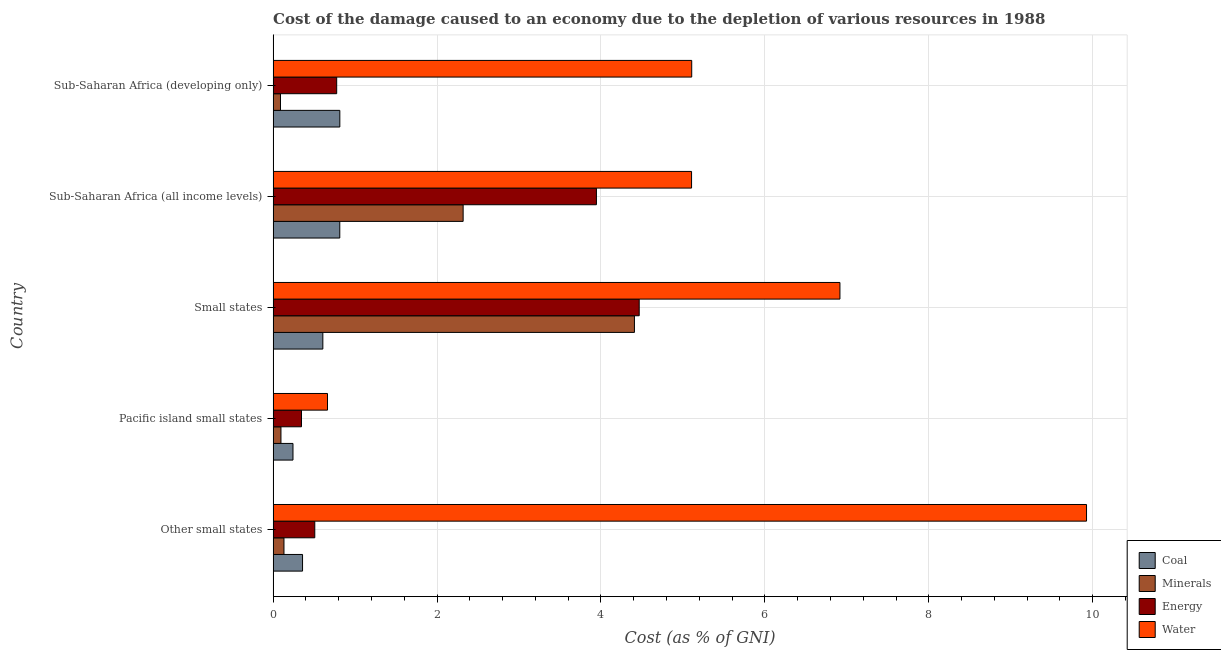How many different coloured bars are there?
Keep it short and to the point. 4. What is the label of the 4th group of bars from the top?
Your answer should be very brief. Pacific island small states. What is the cost of damage due to depletion of coal in Small states?
Keep it short and to the point. 0.61. Across all countries, what is the maximum cost of damage due to depletion of energy?
Offer a very short reply. 4.47. Across all countries, what is the minimum cost of damage due to depletion of energy?
Offer a terse response. 0.35. In which country was the cost of damage due to depletion of minerals maximum?
Your answer should be compact. Small states. In which country was the cost of damage due to depletion of energy minimum?
Keep it short and to the point. Pacific island small states. What is the total cost of damage due to depletion of coal in the graph?
Your response must be concise. 2.84. What is the difference between the cost of damage due to depletion of coal in Other small states and that in Pacific island small states?
Your response must be concise. 0.12. What is the difference between the cost of damage due to depletion of water in Small states and the cost of damage due to depletion of minerals in Other small states?
Your answer should be very brief. 6.78. What is the average cost of damage due to depletion of coal per country?
Your answer should be very brief. 0.57. What is the difference between the cost of damage due to depletion of coal and cost of damage due to depletion of minerals in Sub-Saharan Africa (developing only)?
Provide a succinct answer. 0.72. In how many countries, is the cost of damage due to depletion of coal greater than 0.4 %?
Offer a terse response. 3. What is the ratio of the cost of damage due to depletion of coal in Other small states to that in Sub-Saharan Africa (developing only)?
Your answer should be very brief. 0.44. Is the cost of damage due to depletion of energy in Small states less than that in Sub-Saharan Africa (all income levels)?
Provide a succinct answer. No. Is the difference between the cost of damage due to depletion of minerals in Pacific island small states and Sub-Saharan Africa (all income levels) greater than the difference between the cost of damage due to depletion of water in Pacific island small states and Sub-Saharan Africa (all income levels)?
Offer a terse response. Yes. What is the difference between the highest and the second highest cost of damage due to depletion of minerals?
Offer a very short reply. 2.09. What is the difference between the highest and the lowest cost of damage due to depletion of coal?
Your response must be concise. 0.57. In how many countries, is the cost of damage due to depletion of coal greater than the average cost of damage due to depletion of coal taken over all countries?
Provide a short and direct response. 3. What does the 4th bar from the top in Sub-Saharan Africa (all income levels) represents?
Your answer should be compact. Coal. What does the 3rd bar from the bottom in Sub-Saharan Africa (developing only) represents?
Make the answer very short. Energy. How many countries are there in the graph?
Ensure brevity in your answer.  5. What is the difference between two consecutive major ticks on the X-axis?
Provide a succinct answer. 2. Does the graph contain any zero values?
Offer a terse response. No. How are the legend labels stacked?
Keep it short and to the point. Vertical. What is the title of the graph?
Make the answer very short. Cost of the damage caused to an economy due to the depletion of various resources in 1988 . What is the label or title of the X-axis?
Your answer should be very brief. Cost (as % of GNI). What is the label or title of the Y-axis?
Offer a terse response. Country. What is the Cost (as % of GNI) of Coal in Other small states?
Your response must be concise. 0.36. What is the Cost (as % of GNI) of Minerals in Other small states?
Your answer should be compact. 0.13. What is the Cost (as % of GNI) of Energy in Other small states?
Make the answer very short. 0.51. What is the Cost (as % of GNI) in Water in Other small states?
Your response must be concise. 9.92. What is the Cost (as % of GNI) of Coal in Pacific island small states?
Give a very brief answer. 0.24. What is the Cost (as % of GNI) of Minerals in Pacific island small states?
Provide a short and direct response. 0.1. What is the Cost (as % of GNI) of Energy in Pacific island small states?
Offer a terse response. 0.35. What is the Cost (as % of GNI) of Water in Pacific island small states?
Your answer should be very brief. 0.66. What is the Cost (as % of GNI) in Coal in Small states?
Make the answer very short. 0.61. What is the Cost (as % of GNI) of Minerals in Small states?
Your answer should be very brief. 4.41. What is the Cost (as % of GNI) of Energy in Small states?
Give a very brief answer. 4.47. What is the Cost (as % of GNI) in Water in Small states?
Provide a short and direct response. 6.92. What is the Cost (as % of GNI) in Coal in Sub-Saharan Africa (all income levels)?
Offer a terse response. 0.81. What is the Cost (as % of GNI) of Minerals in Sub-Saharan Africa (all income levels)?
Offer a terse response. 2.32. What is the Cost (as % of GNI) in Energy in Sub-Saharan Africa (all income levels)?
Provide a succinct answer. 3.94. What is the Cost (as % of GNI) in Water in Sub-Saharan Africa (all income levels)?
Make the answer very short. 5.11. What is the Cost (as % of GNI) in Coal in Sub-Saharan Africa (developing only)?
Offer a terse response. 0.81. What is the Cost (as % of GNI) of Minerals in Sub-Saharan Africa (developing only)?
Provide a succinct answer. 0.09. What is the Cost (as % of GNI) of Energy in Sub-Saharan Africa (developing only)?
Your answer should be very brief. 0.78. What is the Cost (as % of GNI) of Water in Sub-Saharan Africa (developing only)?
Ensure brevity in your answer.  5.11. Across all countries, what is the maximum Cost (as % of GNI) of Coal?
Your response must be concise. 0.81. Across all countries, what is the maximum Cost (as % of GNI) of Minerals?
Give a very brief answer. 4.41. Across all countries, what is the maximum Cost (as % of GNI) of Energy?
Make the answer very short. 4.47. Across all countries, what is the maximum Cost (as % of GNI) in Water?
Offer a very short reply. 9.92. Across all countries, what is the minimum Cost (as % of GNI) in Coal?
Provide a short and direct response. 0.24. Across all countries, what is the minimum Cost (as % of GNI) in Minerals?
Keep it short and to the point. 0.09. Across all countries, what is the minimum Cost (as % of GNI) in Energy?
Your answer should be compact. 0.35. Across all countries, what is the minimum Cost (as % of GNI) of Water?
Your answer should be very brief. 0.66. What is the total Cost (as % of GNI) of Coal in the graph?
Give a very brief answer. 2.84. What is the total Cost (as % of GNI) of Minerals in the graph?
Your answer should be very brief. 7.04. What is the total Cost (as % of GNI) in Energy in the graph?
Keep it short and to the point. 10.04. What is the total Cost (as % of GNI) in Water in the graph?
Offer a terse response. 27.72. What is the difference between the Cost (as % of GNI) in Coal in Other small states and that in Pacific island small states?
Your answer should be very brief. 0.12. What is the difference between the Cost (as % of GNI) in Minerals in Other small states and that in Pacific island small states?
Your response must be concise. 0.04. What is the difference between the Cost (as % of GNI) in Energy in Other small states and that in Pacific island small states?
Offer a very short reply. 0.16. What is the difference between the Cost (as % of GNI) of Water in Other small states and that in Pacific island small states?
Provide a short and direct response. 9.26. What is the difference between the Cost (as % of GNI) of Coal in Other small states and that in Small states?
Offer a terse response. -0.25. What is the difference between the Cost (as % of GNI) of Minerals in Other small states and that in Small states?
Your answer should be very brief. -4.28. What is the difference between the Cost (as % of GNI) of Energy in Other small states and that in Small states?
Offer a very short reply. -3.96. What is the difference between the Cost (as % of GNI) in Water in Other small states and that in Small states?
Keep it short and to the point. 3.01. What is the difference between the Cost (as % of GNI) in Coal in Other small states and that in Sub-Saharan Africa (all income levels)?
Offer a terse response. -0.45. What is the difference between the Cost (as % of GNI) in Minerals in Other small states and that in Sub-Saharan Africa (all income levels)?
Your response must be concise. -2.19. What is the difference between the Cost (as % of GNI) of Energy in Other small states and that in Sub-Saharan Africa (all income levels)?
Your answer should be very brief. -3.44. What is the difference between the Cost (as % of GNI) of Water in Other small states and that in Sub-Saharan Africa (all income levels)?
Your response must be concise. 4.82. What is the difference between the Cost (as % of GNI) of Coal in Other small states and that in Sub-Saharan Africa (developing only)?
Make the answer very short. -0.45. What is the difference between the Cost (as % of GNI) in Minerals in Other small states and that in Sub-Saharan Africa (developing only)?
Your response must be concise. 0.04. What is the difference between the Cost (as % of GNI) in Energy in Other small states and that in Sub-Saharan Africa (developing only)?
Offer a terse response. -0.27. What is the difference between the Cost (as % of GNI) in Water in Other small states and that in Sub-Saharan Africa (developing only)?
Provide a short and direct response. 4.82. What is the difference between the Cost (as % of GNI) of Coal in Pacific island small states and that in Small states?
Offer a terse response. -0.36. What is the difference between the Cost (as % of GNI) of Minerals in Pacific island small states and that in Small states?
Your response must be concise. -4.31. What is the difference between the Cost (as % of GNI) in Energy in Pacific island small states and that in Small states?
Your answer should be very brief. -4.12. What is the difference between the Cost (as % of GNI) in Water in Pacific island small states and that in Small states?
Make the answer very short. -6.25. What is the difference between the Cost (as % of GNI) in Coal in Pacific island small states and that in Sub-Saharan Africa (all income levels)?
Give a very brief answer. -0.57. What is the difference between the Cost (as % of GNI) in Minerals in Pacific island small states and that in Sub-Saharan Africa (all income levels)?
Your response must be concise. -2.22. What is the difference between the Cost (as % of GNI) of Energy in Pacific island small states and that in Sub-Saharan Africa (all income levels)?
Provide a short and direct response. -3.6. What is the difference between the Cost (as % of GNI) of Water in Pacific island small states and that in Sub-Saharan Africa (all income levels)?
Provide a short and direct response. -4.44. What is the difference between the Cost (as % of GNI) in Coal in Pacific island small states and that in Sub-Saharan Africa (developing only)?
Keep it short and to the point. -0.57. What is the difference between the Cost (as % of GNI) of Minerals in Pacific island small states and that in Sub-Saharan Africa (developing only)?
Ensure brevity in your answer.  0.01. What is the difference between the Cost (as % of GNI) in Energy in Pacific island small states and that in Sub-Saharan Africa (developing only)?
Offer a terse response. -0.43. What is the difference between the Cost (as % of GNI) in Water in Pacific island small states and that in Sub-Saharan Africa (developing only)?
Provide a short and direct response. -4.44. What is the difference between the Cost (as % of GNI) in Coal in Small states and that in Sub-Saharan Africa (all income levels)?
Make the answer very short. -0.21. What is the difference between the Cost (as % of GNI) of Minerals in Small states and that in Sub-Saharan Africa (all income levels)?
Offer a terse response. 2.09. What is the difference between the Cost (as % of GNI) in Energy in Small states and that in Sub-Saharan Africa (all income levels)?
Make the answer very short. 0.52. What is the difference between the Cost (as % of GNI) of Water in Small states and that in Sub-Saharan Africa (all income levels)?
Your answer should be compact. 1.81. What is the difference between the Cost (as % of GNI) of Coal in Small states and that in Sub-Saharan Africa (developing only)?
Give a very brief answer. -0.21. What is the difference between the Cost (as % of GNI) in Minerals in Small states and that in Sub-Saharan Africa (developing only)?
Your answer should be very brief. 4.32. What is the difference between the Cost (as % of GNI) in Energy in Small states and that in Sub-Saharan Africa (developing only)?
Your answer should be very brief. 3.69. What is the difference between the Cost (as % of GNI) of Water in Small states and that in Sub-Saharan Africa (developing only)?
Your answer should be compact. 1.81. What is the difference between the Cost (as % of GNI) of Coal in Sub-Saharan Africa (all income levels) and that in Sub-Saharan Africa (developing only)?
Ensure brevity in your answer.  -0. What is the difference between the Cost (as % of GNI) in Minerals in Sub-Saharan Africa (all income levels) and that in Sub-Saharan Africa (developing only)?
Provide a short and direct response. 2.23. What is the difference between the Cost (as % of GNI) in Energy in Sub-Saharan Africa (all income levels) and that in Sub-Saharan Africa (developing only)?
Offer a terse response. 3.17. What is the difference between the Cost (as % of GNI) of Water in Sub-Saharan Africa (all income levels) and that in Sub-Saharan Africa (developing only)?
Your answer should be compact. -0. What is the difference between the Cost (as % of GNI) of Coal in Other small states and the Cost (as % of GNI) of Minerals in Pacific island small states?
Give a very brief answer. 0.26. What is the difference between the Cost (as % of GNI) of Coal in Other small states and the Cost (as % of GNI) of Energy in Pacific island small states?
Provide a short and direct response. 0.01. What is the difference between the Cost (as % of GNI) in Coal in Other small states and the Cost (as % of GNI) in Water in Pacific island small states?
Provide a short and direct response. -0.3. What is the difference between the Cost (as % of GNI) in Minerals in Other small states and the Cost (as % of GNI) in Energy in Pacific island small states?
Provide a short and direct response. -0.21. What is the difference between the Cost (as % of GNI) in Minerals in Other small states and the Cost (as % of GNI) in Water in Pacific island small states?
Ensure brevity in your answer.  -0.53. What is the difference between the Cost (as % of GNI) in Energy in Other small states and the Cost (as % of GNI) in Water in Pacific island small states?
Your answer should be compact. -0.16. What is the difference between the Cost (as % of GNI) of Coal in Other small states and the Cost (as % of GNI) of Minerals in Small states?
Provide a succinct answer. -4.05. What is the difference between the Cost (as % of GNI) in Coal in Other small states and the Cost (as % of GNI) in Energy in Small states?
Offer a very short reply. -4.11. What is the difference between the Cost (as % of GNI) in Coal in Other small states and the Cost (as % of GNI) in Water in Small states?
Keep it short and to the point. -6.56. What is the difference between the Cost (as % of GNI) of Minerals in Other small states and the Cost (as % of GNI) of Energy in Small states?
Keep it short and to the point. -4.33. What is the difference between the Cost (as % of GNI) in Minerals in Other small states and the Cost (as % of GNI) in Water in Small states?
Provide a short and direct response. -6.78. What is the difference between the Cost (as % of GNI) in Energy in Other small states and the Cost (as % of GNI) in Water in Small states?
Make the answer very short. -6.41. What is the difference between the Cost (as % of GNI) in Coal in Other small states and the Cost (as % of GNI) in Minerals in Sub-Saharan Africa (all income levels)?
Keep it short and to the point. -1.96. What is the difference between the Cost (as % of GNI) of Coal in Other small states and the Cost (as % of GNI) of Energy in Sub-Saharan Africa (all income levels)?
Offer a terse response. -3.59. What is the difference between the Cost (as % of GNI) in Coal in Other small states and the Cost (as % of GNI) in Water in Sub-Saharan Africa (all income levels)?
Your answer should be compact. -4.75. What is the difference between the Cost (as % of GNI) in Minerals in Other small states and the Cost (as % of GNI) in Energy in Sub-Saharan Africa (all income levels)?
Your response must be concise. -3.81. What is the difference between the Cost (as % of GNI) of Minerals in Other small states and the Cost (as % of GNI) of Water in Sub-Saharan Africa (all income levels)?
Offer a very short reply. -4.97. What is the difference between the Cost (as % of GNI) in Energy in Other small states and the Cost (as % of GNI) in Water in Sub-Saharan Africa (all income levels)?
Your response must be concise. -4.6. What is the difference between the Cost (as % of GNI) in Coal in Other small states and the Cost (as % of GNI) in Minerals in Sub-Saharan Africa (developing only)?
Offer a terse response. 0.27. What is the difference between the Cost (as % of GNI) of Coal in Other small states and the Cost (as % of GNI) of Energy in Sub-Saharan Africa (developing only)?
Offer a very short reply. -0.42. What is the difference between the Cost (as % of GNI) in Coal in Other small states and the Cost (as % of GNI) in Water in Sub-Saharan Africa (developing only)?
Provide a succinct answer. -4.75. What is the difference between the Cost (as % of GNI) of Minerals in Other small states and the Cost (as % of GNI) of Energy in Sub-Saharan Africa (developing only)?
Your response must be concise. -0.64. What is the difference between the Cost (as % of GNI) in Minerals in Other small states and the Cost (as % of GNI) in Water in Sub-Saharan Africa (developing only)?
Provide a short and direct response. -4.97. What is the difference between the Cost (as % of GNI) in Energy in Other small states and the Cost (as % of GNI) in Water in Sub-Saharan Africa (developing only)?
Offer a terse response. -4.6. What is the difference between the Cost (as % of GNI) in Coal in Pacific island small states and the Cost (as % of GNI) in Minerals in Small states?
Ensure brevity in your answer.  -4.17. What is the difference between the Cost (as % of GNI) of Coal in Pacific island small states and the Cost (as % of GNI) of Energy in Small states?
Your answer should be very brief. -4.22. What is the difference between the Cost (as % of GNI) of Coal in Pacific island small states and the Cost (as % of GNI) of Water in Small states?
Make the answer very short. -6.67. What is the difference between the Cost (as % of GNI) of Minerals in Pacific island small states and the Cost (as % of GNI) of Energy in Small states?
Make the answer very short. -4.37. What is the difference between the Cost (as % of GNI) of Minerals in Pacific island small states and the Cost (as % of GNI) of Water in Small states?
Your answer should be compact. -6.82. What is the difference between the Cost (as % of GNI) in Energy in Pacific island small states and the Cost (as % of GNI) in Water in Small states?
Your answer should be very brief. -6.57. What is the difference between the Cost (as % of GNI) in Coal in Pacific island small states and the Cost (as % of GNI) in Minerals in Sub-Saharan Africa (all income levels)?
Your answer should be compact. -2.08. What is the difference between the Cost (as % of GNI) in Coal in Pacific island small states and the Cost (as % of GNI) in Energy in Sub-Saharan Africa (all income levels)?
Give a very brief answer. -3.7. What is the difference between the Cost (as % of GNI) of Coal in Pacific island small states and the Cost (as % of GNI) of Water in Sub-Saharan Africa (all income levels)?
Offer a very short reply. -4.86. What is the difference between the Cost (as % of GNI) in Minerals in Pacific island small states and the Cost (as % of GNI) in Energy in Sub-Saharan Africa (all income levels)?
Your answer should be compact. -3.85. What is the difference between the Cost (as % of GNI) in Minerals in Pacific island small states and the Cost (as % of GNI) in Water in Sub-Saharan Africa (all income levels)?
Your response must be concise. -5.01. What is the difference between the Cost (as % of GNI) in Energy in Pacific island small states and the Cost (as % of GNI) in Water in Sub-Saharan Africa (all income levels)?
Your response must be concise. -4.76. What is the difference between the Cost (as % of GNI) in Coal in Pacific island small states and the Cost (as % of GNI) in Minerals in Sub-Saharan Africa (developing only)?
Provide a succinct answer. 0.15. What is the difference between the Cost (as % of GNI) in Coal in Pacific island small states and the Cost (as % of GNI) in Energy in Sub-Saharan Africa (developing only)?
Make the answer very short. -0.53. What is the difference between the Cost (as % of GNI) in Coal in Pacific island small states and the Cost (as % of GNI) in Water in Sub-Saharan Africa (developing only)?
Your answer should be very brief. -4.86. What is the difference between the Cost (as % of GNI) of Minerals in Pacific island small states and the Cost (as % of GNI) of Energy in Sub-Saharan Africa (developing only)?
Offer a terse response. -0.68. What is the difference between the Cost (as % of GNI) of Minerals in Pacific island small states and the Cost (as % of GNI) of Water in Sub-Saharan Africa (developing only)?
Give a very brief answer. -5.01. What is the difference between the Cost (as % of GNI) of Energy in Pacific island small states and the Cost (as % of GNI) of Water in Sub-Saharan Africa (developing only)?
Offer a very short reply. -4.76. What is the difference between the Cost (as % of GNI) in Coal in Small states and the Cost (as % of GNI) in Minerals in Sub-Saharan Africa (all income levels)?
Ensure brevity in your answer.  -1.71. What is the difference between the Cost (as % of GNI) in Coal in Small states and the Cost (as % of GNI) in Energy in Sub-Saharan Africa (all income levels)?
Provide a short and direct response. -3.34. What is the difference between the Cost (as % of GNI) in Coal in Small states and the Cost (as % of GNI) in Water in Sub-Saharan Africa (all income levels)?
Your answer should be very brief. -4.5. What is the difference between the Cost (as % of GNI) of Minerals in Small states and the Cost (as % of GNI) of Energy in Sub-Saharan Africa (all income levels)?
Your answer should be compact. 0.46. What is the difference between the Cost (as % of GNI) in Minerals in Small states and the Cost (as % of GNI) in Water in Sub-Saharan Africa (all income levels)?
Keep it short and to the point. -0.7. What is the difference between the Cost (as % of GNI) in Energy in Small states and the Cost (as % of GNI) in Water in Sub-Saharan Africa (all income levels)?
Provide a short and direct response. -0.64. What is the difference between the Cost (as % of GNI) in Coal in Small states and the Cost (as % of GNI) in Minerals in Sub-Saharan Africa (developing only)?
Offer a terse response. 0.52. What is the difference between the Cost (as % of GNI) of Coal in Small states and the Cost (as % of GNI) of Energy in Sub-Saharan Africa (developing only)?
Give a very brief answer. -0.17. What is the difference between the Cost (as % of GNI) in Coal in Small states and the Cost (as % of GNI) in Water in Sub-Saharan Africa (developing only)?
Your answer should be very brief. -4.5. What is the difference between the Cost (as % of GNI) of Minerals in Small states and the Cost (as % of GNI) of Energy in Sub-Saharan Africa (developing only)?
Keep it short and to the point. 3.63. What is the difference between the Cost (as % of GNI) in Minerals in Small states and the Cost (as % of GNI) in Water in Sub-Saharan Africa (developing only)?
Provide a succinct answer. -0.7. What is the difference between the Cost (as % of GNI) in Energy in Small states and the Cost (as % of GNI) in Water in Sub-Saharan Africa (developing only)?
Your answer should be very brief. -0.64. What is the difference between the Cost (as % of GNI) of Coal in Sub-Saharan Africa (all income levels) and the Cost (as % of GNI) of Minerals in Sub-Saharan Africa (developing only)?
Give a very brief answer. 0.72. What is the difference between the Cost (as % of GNI) in Coal in Sub-Saharan Africa (all income levels) and the Cost (as % of GNI) in Energy in Sub-Saharan Africa (developing only)?
Make the answer very short. 0.04. What is the difference between the Cost (as % of GNI) in Coal in Sub-Saharan Africa (all income levels) and the Cost (as % of GNI) in Water in Sub-Saharan Africa (developing only)?
Your answer should be compact. -4.29. What is the difference between the Cost (as % of GNI) of Minerals in Sub-Saharan Africa (all income levels) and the Cost (as % of GNI) of Energy in Sub-Saharan Africa (developing only)?
Provide a short and direct response. 1.54. What is the difference between the Cost (as % of GNI) in Minerals in Sub-Saharan Africa (all income levels) and the Cost (as % of GNI) in Water in Sub-Saharan Africa (developing only)?
Offer a very short reply. -2.79. What is the difference between the Cost (as % of GNI) of Energy in Sub-Saharan Africa (all income levels) and the Cost (as % of GNI) of Water in Sub-Saharan Africa (developing only)?
Your response must be concise. -1.16. What is the average Cost (as % of GNI) of Coal per country?
Provide a short and direct response. 0.57. What is the average Cost (as % of GNI) in Minerals per country?
Make the answer very short. 1.41. What is the average Cost (as % of GNI) of Energy per country?
Your answer should be very brief. 2.01. What is the average Cost (as % of GNI) in Water per country?
Your response must be concise. 5.54. What is the difference between the Cost (as % of GNI) of Coal and Cost (as % of GNI) of Minerals in Other small states?
Make the answer very short. 0.23. What is the difference between the Cost (as % of GNI) of Coal and Cost (as % of GNI) of Energy in Other small states?
Keep it short and to the point. -0.15. What is the difference between the Cost (as % of GNI) of Coal and Cost (as % of GNI) of Water in Other small states?
Provide a short and direct response. -9.57. What is the difference between the Cost (as % of GNI) of Minerals and Cost (as % of GNI) of Energy in Other small states?
Offer a very short reply. -0.38. What is the difference between the Cost (as % of GNI) of Minerals and Cost (as % of GNI) of Water in Other small states?
Give a very brief answer. -9.79. What is the difference between the Cost (as % of GNI) of Energy and Cost (as % of GNI) of Water in Other small states?
Your answer should be compact. -9.42. What is the difference between the Cost (as % of GNI) of Coal and Cost (as % of GNI) of Minerals in Pacific island small states?
Provide a succinct answer. 0.15. What is the difference between the Cost (as % of GNI) in Coal and Cost (as % of GNI) in Energy in Pacific island small states?
Offer a very short reply. -0.1. What is the difference between the Cost (as % of GNI) in Coal and Cost (as % of GNI) in Water in Pacific island small states?
Provide a succinct answer. -0.42. What is the difference between the Cost (as % of GNI) in Minerals and Cost (as % of GNI) in Energy in Pacific island small states?
Provide a succinct answer. -0.25. What is the difference between the Cost (as % of GNI) of Minerals and Cost (as % of GNI) of Water in Pacific island small states?
Keep it short and to the point. -0.57. What is the difference between the Cost (as % of GNI) of Energy and Cost (as % of GNI) of Water in Pacific island small states?
Provide a short and direct response. -0.32. What is the difference between the Cost (as % of GNI) in Coal and Cost (as % of GNI) in Minerals in Small states?
Your answer should be very brief. -3.8. What is the difference between the Cost (as % of GNI) in Coal and Cost (as % of GNI) in Energy in Small states?
Provide a short and direct response. -3.86. What is the difference between the Cost (as % of GNI) of Coal and Cost (as % of GNI) of Water in Small states?
Ensure brevity in your answer.  -6.31. What is the difference between the Cost (as % of GNI) in Minerals and Cost (as % of GNI) in Energy in Small states?
Provide a short and direct response. -0.06. What is the difference between the Cost (as % of GNI) in Minerals and Cost (as % of GNI) in Water in Small states?
Your response must be concise. -2.51. What is the difference between the Cost (as % of GNI) in Energy and Cost (as % of GNI) in Water in Small states?
Your answer should be compact. -2.45. What is the difference between the Cost (as % of GNI) in Coal and Cost (as % of GNI) in Minerals in Sub-Saharan Africa (all income levels)?
Make the answer very short. -1.51. What is the difference between the Cost (as % of GNI) of Coal and Cost (as % of GNI) of Energy in Sub-Saharan Africa (all income levels)?
Your answer should be very brief. -3.13. What is the difference between the Cost (as % of GNI) of Coal and Cost (as % of GNI) of Water in Sub-Saharan Africa (all income levels)?
Your answer should be very brief. -4.29. What is the difference between the Cost (as % of GNI) in Minerals and Cost (as % of GNI) in Energy in Sub-Saharan Africa (all income levels)?
Your answer should be compact. -1.63. What is the difference between the Cost (as % of GNI) in Minerals and Cost (as % of GNI) in Water in Sub-Saharan Africa (all income levels)?
Your answer should be very brief. -2.79. What is the difference between the Cost (as % of GNI) of Energy and Cost (as % of GNI) of Water in Sub-Saharan Africa (all income levels)?
Your answer should be compact. -1.16. What is the difference between the Cost (as % of GNI) in Coal and Cost (as % of GNI) in Minerals in Sub-Saharan Africa (developing only)?
Provide a succinct answer. 0.72. What is the difference between the Cost (as % of GNI) of Coal and Cost (as % of GNI) of Energy in Sub-Saharan Africa (developing only)?
Offer a terse response. 0.04. What is the difference between the Cost (as % of GNI) of Coal and Cost (as % of GNI) of Water in Sub-Saharan Africa (developing only)?
Offer a terse response. -4.29. What is the difference between the Cost (as % of GNI) in Minerals and Cost (as % of GNI) in Energy in Sub-Saharan Africa (developing only)?
Provide a short and direct response. -0.69. What is the difference between the Cost (as % of GNI) in Minerals and Cost (as % of GNI) in Water in Sub-Saharan Africa (developing only)?
Give a very brief answer. -5.02. What is the difference between the Cost (as % of GNI) of Energy and Cost (as % of GNI) of Water in Sub-Saharan Africa (developing only)?
Offer a terse response. -4.33. What is the ratio of the Cost (as % of GNI) of Coal in Other small states to that in Pacific island small states?
Ensure brevity in your answer.  1.48. What is the ratio of the Cost (as % of GNI) in Minerals in Other small states to that in Pacific island small states?
Your answer should be very brief. 1.38. What is the ratio of the Cost (as % of GNI) of Energy in Other small states to that in Pacific island small states?
Offer a terse response. 1.47. What is the ratio of the Cost (as % of GNI) of Water in Other small states to that in Pacific island small states?
Give a very brief answer. 14.96. What is the ratio of the Cost (as % of GNI) of Coal in Other small states to that in Small states?
Give a very brief answer. 0.59. What is the ratio of the Cost (as % of GNI) of Energy in Other small states to that in Small states?
Provide a succinct answer. 0.11. What is the ratio of the Cost (as % of GNI) in Water in Other small states to that in Small states?
Your response must be concise. 1.44. What is the ratio of the Cost (as % of GNI) in Coal in Other small states to that in Sub-Saharan Africa (all income levels)?
Your response must be concise. 0.44. What is the ratio of the Cost (as % of GNI) of Minerals in Other small states to that in Sub-Saharan Africa (all income levels)?
Keep it short and to the point. 0.06. What is the ratio of the Cost (as % of GNI) of Energy in Other small states to that in Sub-Saharan Africa (all income levels)?
Your answer should be compact. 0.13. What is the ratio of the Cost (as % of GNI) in Water in Other small states to that in Sub-Saharan Africa (all income levels)?
Ensure brevity in your answer.  1.94. What is the ratio of the Cost (as % of GNI) in Coal in Other small states to that in Sub-Saharan Africa (developing only)?
Your response must be concise. 0.44. What is the ratio of the Cost (as % of GNI) in Minerals in Other small states to that in Sub-Saharan Africa (developing only)?
Offer a terse response. 1.47. What is the ratio of the Cost (as % of GNI) in Energy in Other small states to that in Sub-Saharan Africa (developing only)?
Your response must be concise. 0.66. What is the ratio of the Cost (as % of GNI) in Water in Other small states to that in Sub-Saharan Africa (developing only)?
Provide a short and direct response. 1.94. What is the ratio of the Cost (as % of GNI) of Coal in Pacific island small states to that in Small states?
Offer a very short reply. 0.4. What is the ratio of the Cost (as % of GNI) in Minerals in Pacific island small states to that in Small states?
Your response must be concise. 0.02. What is the ratio of the Cost (as % of GNI) in Energy in Pacific island small states to that in Small states?
Your answer should be very brief. 0.08. What is the ratio of the Cost (as % of GNI) in Water in Pacific island small states to that in Small states?
Your response must be concise. 0.1. What is the ratio of the Cost (as % of GNI) of Coal in Pacific island small states to that in Sub-Saharan Africa (all income levels)?
Your answer should be compact. 0.3. What is the ratio of the Cost (as % of GNI) in Minerals in Pacific island small states to that in Sub-Saharan Africa (all income levels)?
Offer a very short reply. 0.04. What is the ratio of the Cost (as % of GNI) in Energy in Pacific island small states to that in Sub-Saharan Africa (all income levels)?
Your answer should be very brief. 0.09. What is the ratio of the Cost (as % of GNI) of Water in Pacific island small states to that in Sub-Saharan Africa (all income levels)?
Ensure brevity in your answer.  0.13. What is the ratio of the Cost (as % of GNI) in Coal in Pacific island small states to that in Sub-Saharan Africa (developing only)?
Your answer should be very brief. 0.3. What is the ratio of the Cost (as % of GNI) in Minerals in Pacific island small states to that in Sub-Saharan Africa (developing only)?
Offer a very short reply. 1.06. What is the ratio of the Cost (as % of GNI) in Energy in Pacific island small states to that in Sub-Saharan Africa (developing only)?
Your answer should be very brief. 0.45. What is the ratio of the Cost (as % of GNI) of Water in Pacific island small states to that in Sub-Saharan Africa (developing only)?
Ensure brevity in your answer.  0.13. What is the ratio of the Cost (as % of GNI) in Coal in Small states to that in Sub-Saharan Africa (all income levels)?
Keep it short and to the point. 0.75. What is the ratio of the Cost (as % of GNI) of Minerals in Small states to that in Sub-Saharan Africa (all income levels)?
Make the answer very short. 1.9. What is the ratio of the Cost (as % of GNI) of Energy in Small states to that in Sub-Saharan Africa (all income levels)?
Offer a very short reply. 1.13. What is the ratio of the Cost (as % of GNI) in Water in Small states to that in Sub-Saharan Africa (all income levels)?
Make the answer very short. 1.35. What is the ratio of the Cost (as % of GNI) of Coal in Small states to that in Sub-Saharan Africa (developing only)?
Provide a short and direct response. 0.75. What is the ratio of the Cost (as % of GNI) in Minerals in Small states to that in Sub-Saharan Africa (developing only)?
Offer a terse response. 49.08. What is the ratio of the Cost (as % of GNI) of Energy in Small states to that in Sub-Saharan Africa (developing only)?
Provide a succinct answer. 5.76. What is the ratio of the Cost (as % of GNI) in Water in Small states to that in Sub-Saharan Africa (developing only)?
Provide a succinct answer. 1.35. What is the ratio of the Cost (as % of GNI) in Minerals in Sub-Saharan Africa (all income levels) to that in Sub-Saharan Africa (developing only)?
Keep it short and to the point. 25.81. What is the ratio of the Cost (as % of GNI) in Energy in Sub-Saharan Africa (all income levels) to that in Sub-Saharan Africa (developing only)?
Make the answer very short. 5.09. What is the ratio of the Cost (as % of GNI) of Water in Sub-Saharan Africa (all income levels) to that in Sub-Saharan Africa (developing only)?
Your answer should be compact. 1. What is the difference between the highest and the second highest Cost (as % of GNI) of Coal?
Ensure brevity in your answer.  0. What is the difference between the highest and the second highest Cost (as % of GNI) in Minerals?
Keep it short and to the point. 2.09. What is the difference between the highest and the second highest Cost (as % of GNI) of Energy?
Offer a very short reply. 0.52. What is the difference between the highest and the second highest Cost (as % of GNI) in Water?
Your answer should be compact. 3.01. What is the difference between the highest and the lowest Cost (as % of GNI) of Coal?
Your answer should be very brief. 0.57. What is the difference between the highest and the lowest Cost (as % of GNI) in Minerals?
Offer a very short reply. 4.32. What is the difference between the highest and the lowest Cost (as % of GNI) in Energy?
Ensure brevity in your answer.  4.12. What is the difference between the highest and the lowest Cost (as % of GNI) of Water?
Give a very brief answer. 9.26. 